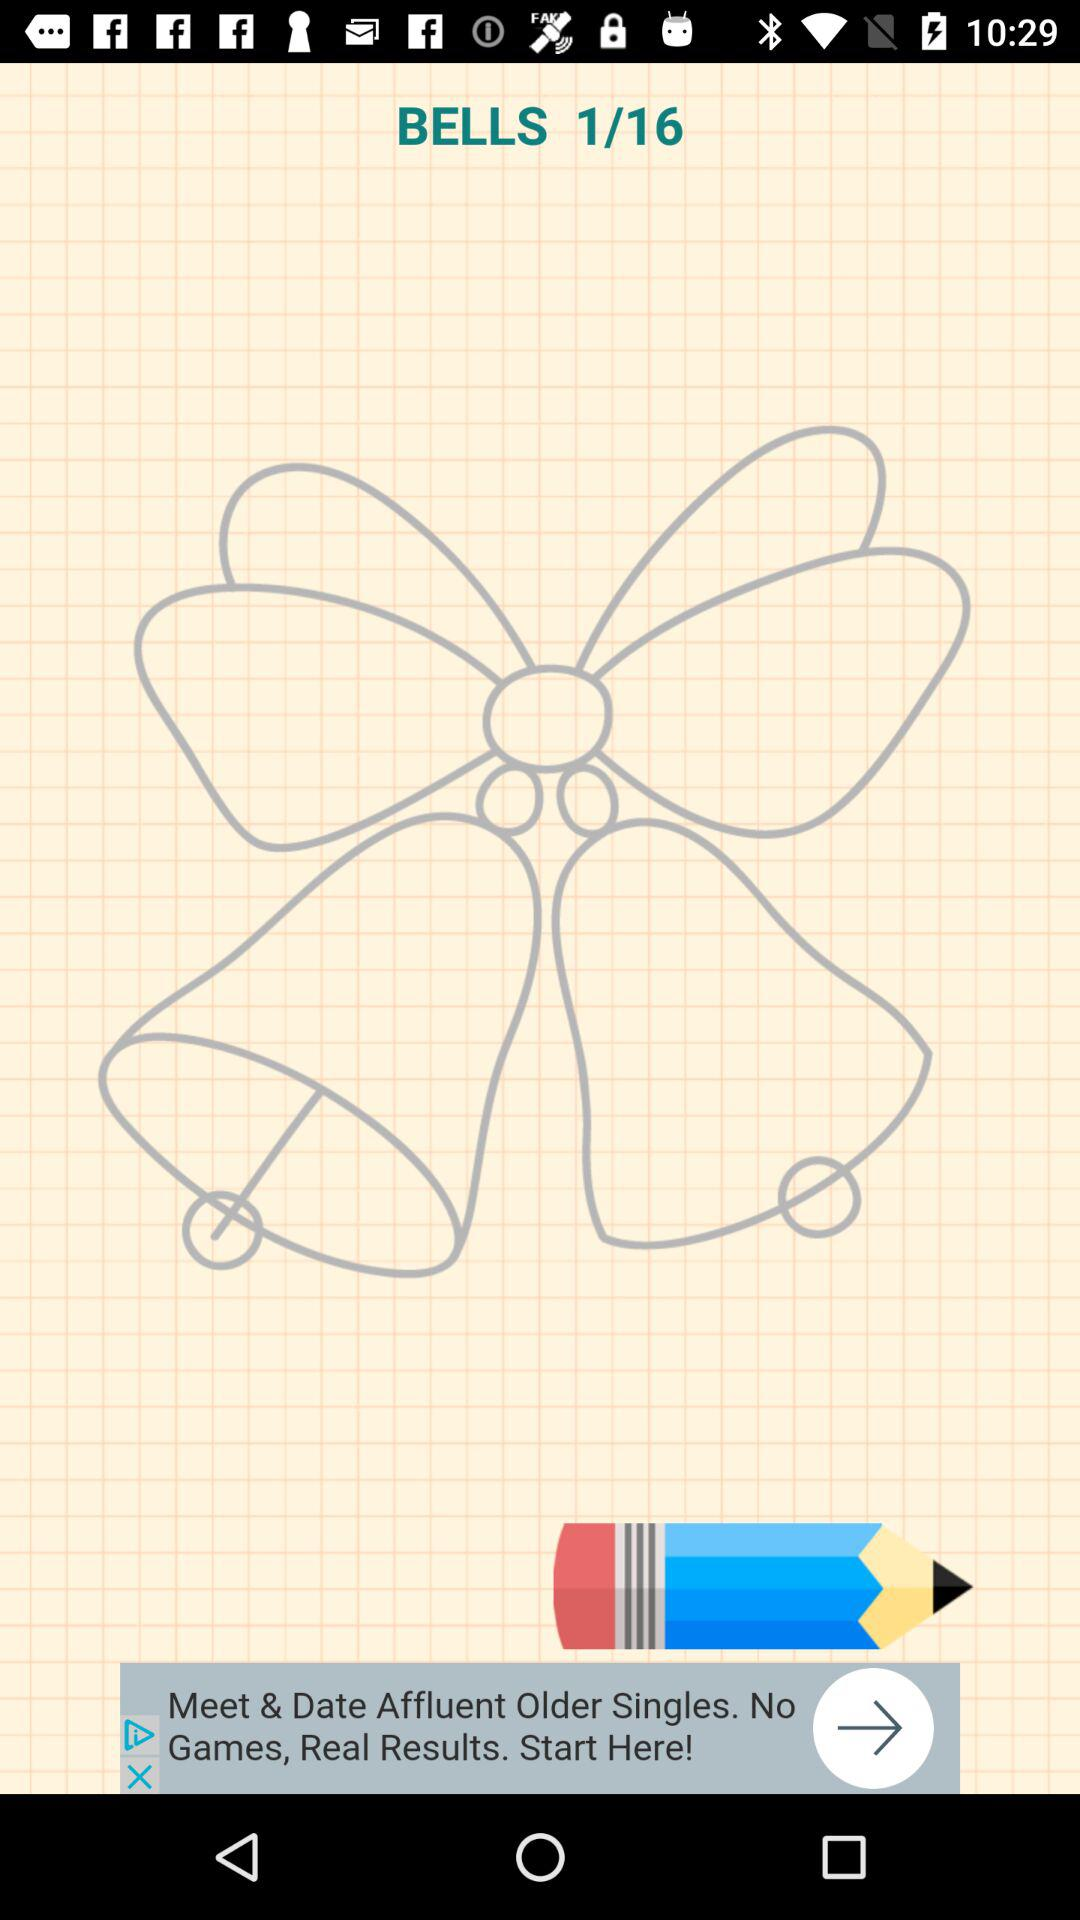How many images in total are there? There are 16 images. 